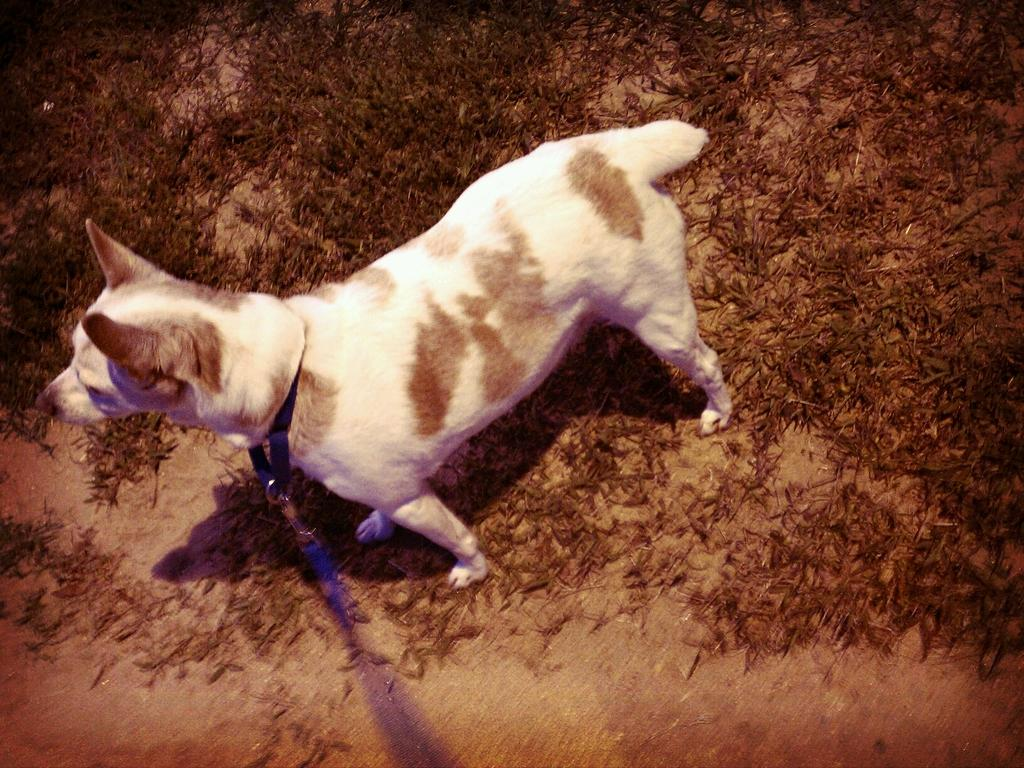What animal is present in the image? There is a dog in the image. What colors can be seen on the dog? The dog is in white and brown color. What type of natural environment is visible in the background of the image? The background of the image includes grass. What type of pencil is the dog using to participate in the competition? There is no pencil or competition present in the image; it features a dog in a grassy environment. What company is sponsoring the dog in the image? There is no company or sponsorship mentioned or depicted in the image. 